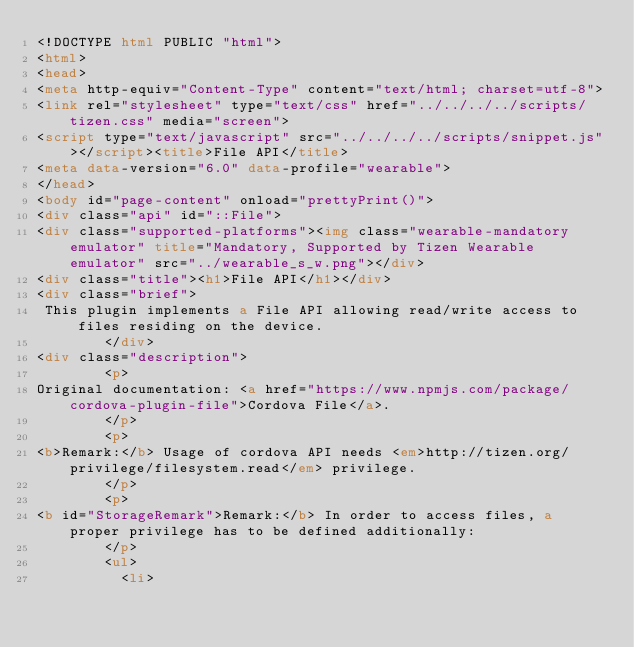<code> <loc_0><loc_0><loc_500><loc_500><_HTML_><!DOCTYPE html PUBLIC "html">
<html>
<head>
<meta http-equiv="Content-Type" content="text/html; charset=utf-8">
<link rel="stylesheet" type="text/css" href="../../../../scripts/tizen.css" media="screen">
<script type="text/javascript" src="../../../../scripts/snippet.js"></script><title>File API</title>
<meta data-version="6.0" data-profile="wearable">
</head>
<body id="page-content" onload="prettyPrint()">
<div class="api" id="::File">
<div class="supported-platforms"><img class="wearable-mandatory emulator" title="Mandatory, Supported by Tizen Wearable emulator" src="../wearable_s_w.png"></div>
<div class="title"><h1>File API</h1></div>
<div class="brief">
 This plugin implements a File API allowing read/write access to files residing on the device.
        </div>
<div class="description">
        <p>
Original documentation: <a href="https://www.npmjs.com/package/cordova-plugin-file">Cordova File</a>.
        </p>
        <p>
<b>Remark:</b> Usage of cordova API needs <em>http://tizen.org/privilege/filesystem.read</em> privilege.
        </p>
        <p>
<b id="StorageRemark">Remark:</b> In order to access files, a proper privilege has to be defined additionally:
        </p>
        <ul>
          <li></code> 